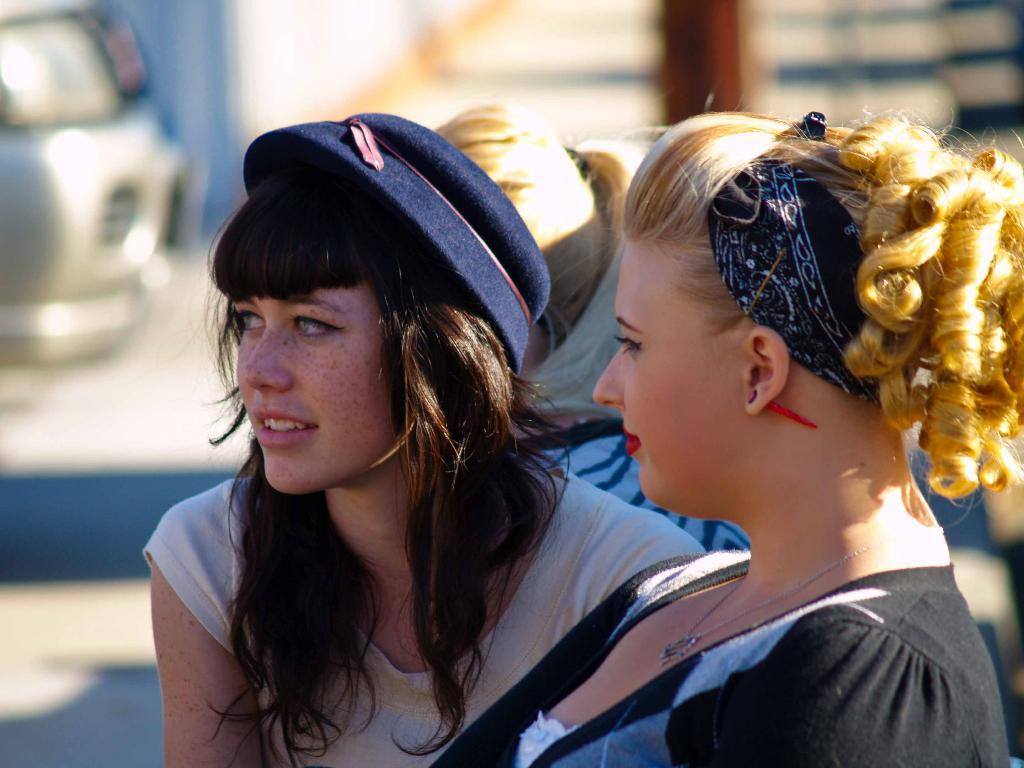How many people are in the image? There are two girls in the image. What are the girls doing in the image? The girls are sitting and looking at someone. Can you describe the appearance of the girls? One girl has golden hair, and the other girl is wearing a hat. What type of advice is the girl with golden hair giving in the image? There is no indication in the image that the girl with golden hair is giving advice; she is simply sitting and looking at someone. How many dimes can be seen in the image? There are no dimes present in the image. 